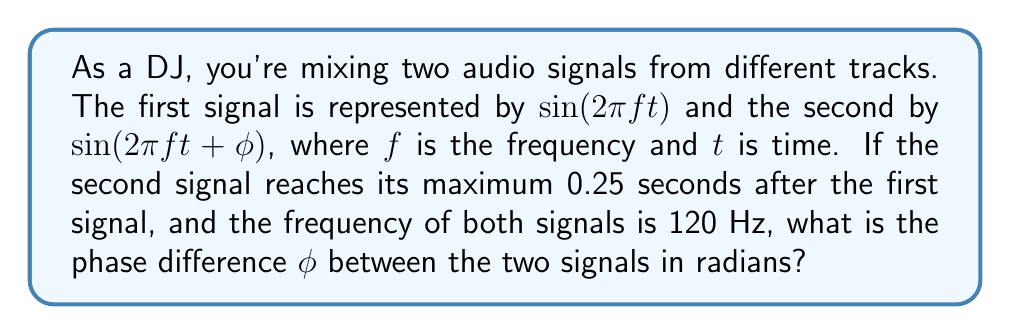Could you help me with this problem? Let's approach this step-by-step:

1) The period $T$ of a signal with frequency $f$ is given by:
   $$T = \frac{1}{f} = \frac{1}{120\text{ Hz}} = \frac{1}{120}\text{ seconds}$$

2) The phase difference in terms of time is 0.25 seconds. Let's call this $\Delta t$.

3) We can express the phase difference as a fraction of the full period:
   $$\frac{\Delta t}{T} = \frac{0.25}{\frac{1}{120}} = 30$$

4) This means the second signal is delayed by 30 full cycles.

5) In terms of angle, one full cycle corresponds to $2\pi$ radians. So our phase difference $\phi$ is:
   $$\phi = 30 \cdot 2\pi = 60\pi\text{ radians}$$

6) However, in trigonometry, we typically express phase differences within one cycle, i.e., between 0 and $2\pi$. We can do this by taking the modulo $2\pi$:
   $$\phi = 60\pi \bmod 2\pi = 0\text{ radians}$$

This makes sense because after 30 full cycles, the signals are back in phase with each other.
Answer: $0$ radians 